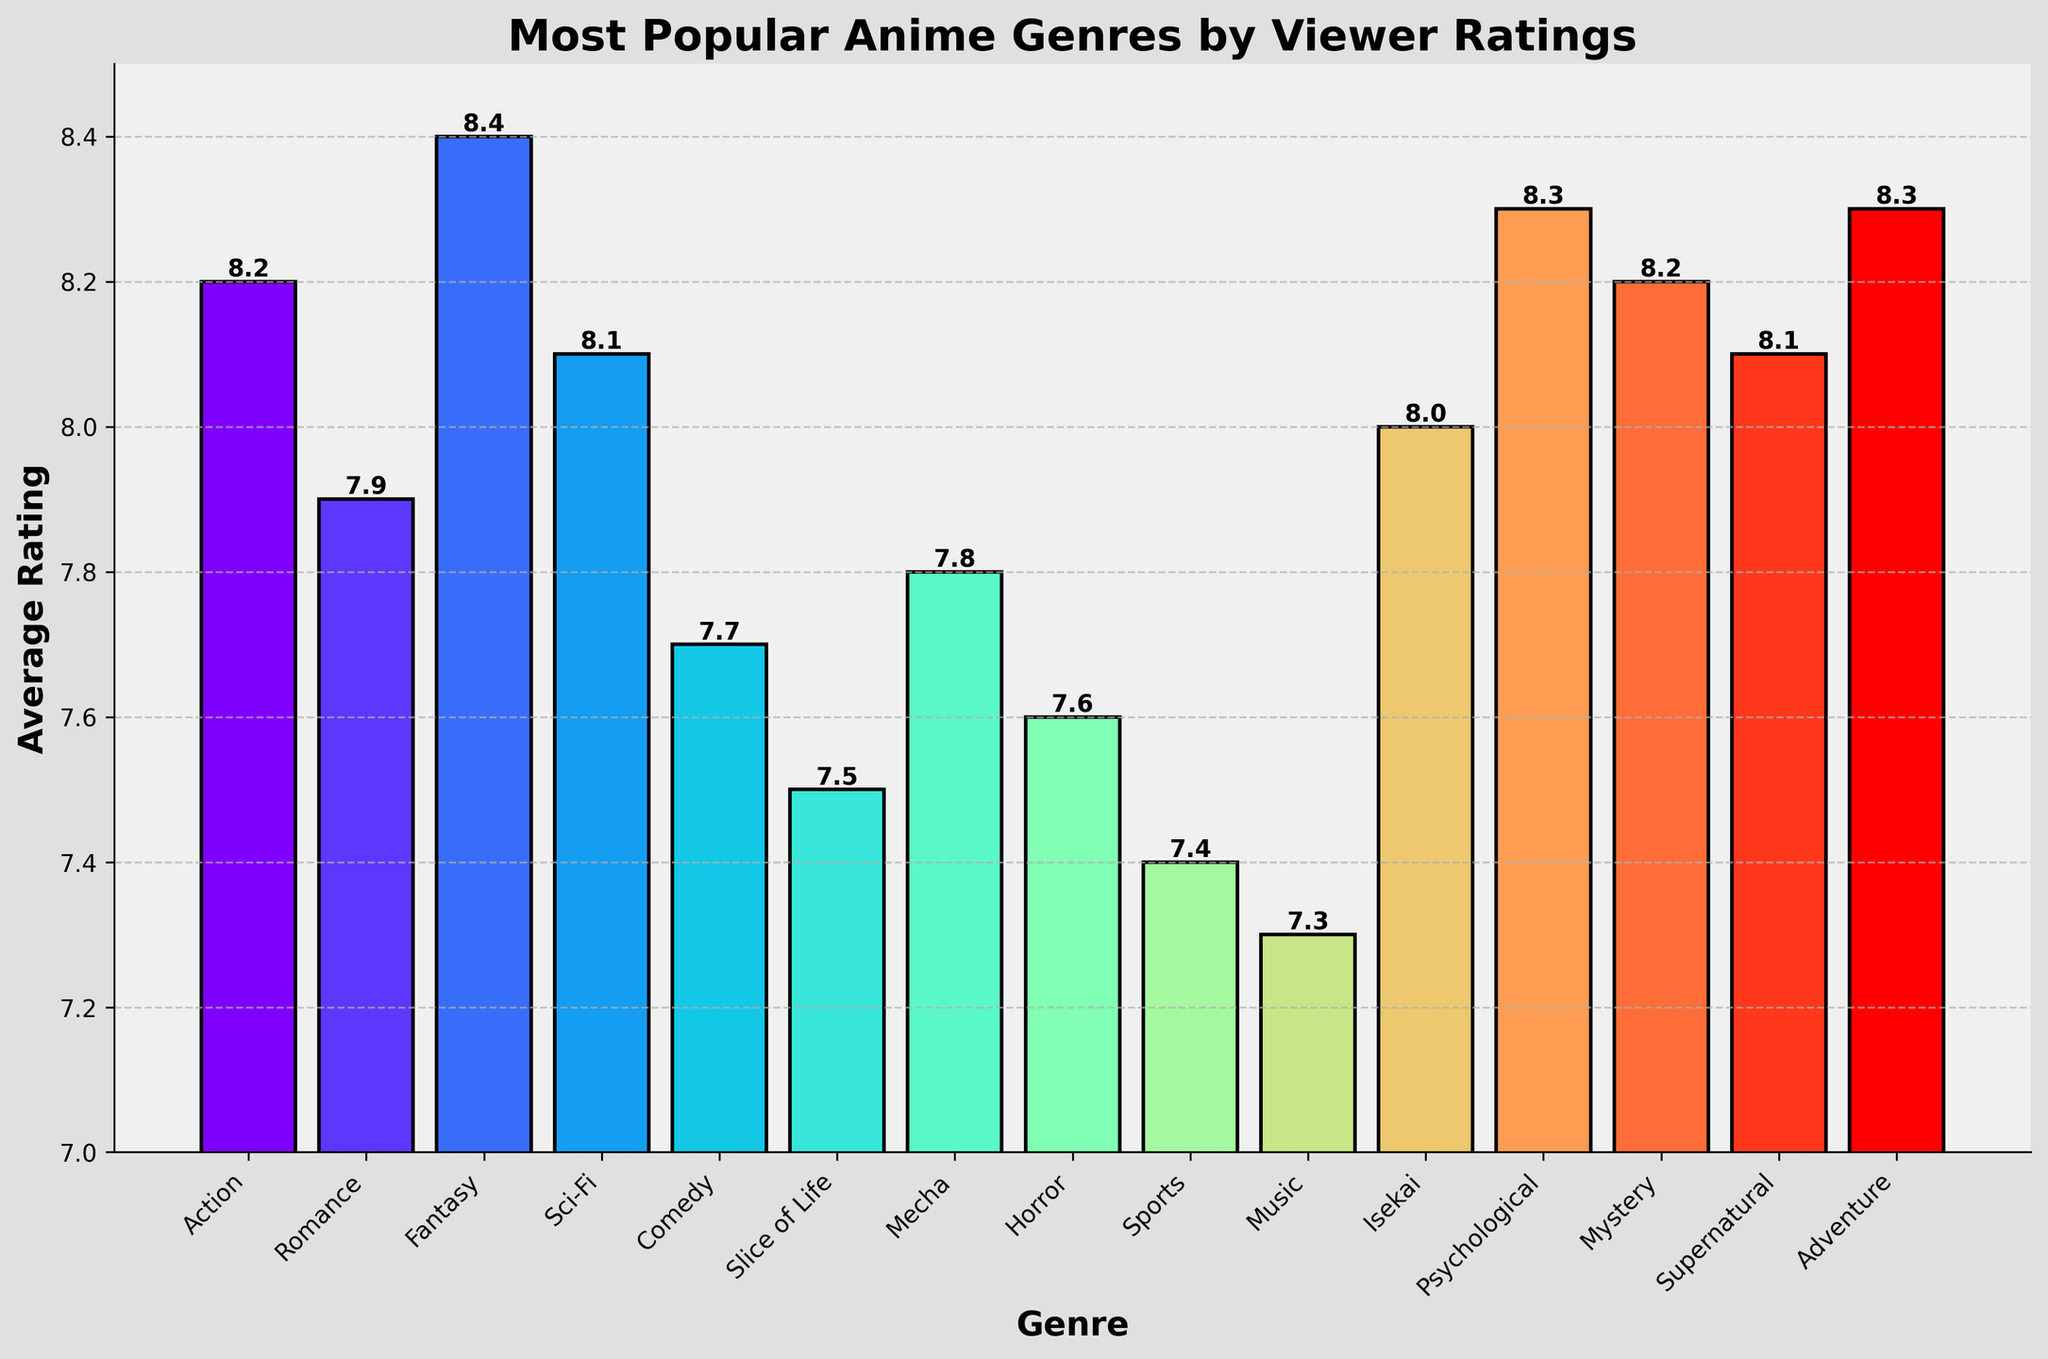Which genre has the highest average rating? Fantasy has the highest average rating since its bar is the tallest, reaching 8.4.
Answer: Fantasy Which genre has the lowest average rating? Music has the lowest average rating as its bar is the shortest, reaching 7.3.
Answer: Music What is the difference in average rating between Fantasy and Romance genres? The average rating for Fantasy is 8.4 and for Romance is 7.9. The difference is 8.4 - 7.9 = 0.5.
Answer: 0.5 How many genres have an average rating of 8.1 or higher? The genres with an average rating of 8.1 or higher are Action (8.2), Fantasy (8.4), Sci-Fi (8.1), Mystery (8.2), and Adventure (8.3), totaling five genres.
Answer: 5 What is the combined average rating of Comedy and Slice of Life? The average rating for Comedy is 7.7 and for Slice of Life is 7.5. The combined average rating is (7.7 + 7.5)/2 = 7.6.
Answer: 7.6 How does the average rating of Mecha compare to Horror? The average rating for Mecha is 7.8, while Horror is 7.6. Therefore, Mecha has a higher average rating than Horror.
Answer: Mecha is higher Which genre has a higher average rating: Psychological or Adventure? Both Psychological and Adventure have an average rating of 8.3, so they are equal.
Answer: They are equal How much higher is the average rating of Action compared to Music? The average rating for Action is 8.2 and for Music is 7.3. The difference is 8.2 - 7.3 = 0.9.
Answer: 0.9 Which genres have an average rating less than 8.0? The genres with less than an 8.0 rating are Romance (7.9), Comedy (7.7), Slice of Life (7.5), Mecha (7.8), Horror (7.6), Sports (7.4), and Music (7.3).
Answer: Romance, Comedy, Slice of Life, Mecha, Horror, Sports, Music 